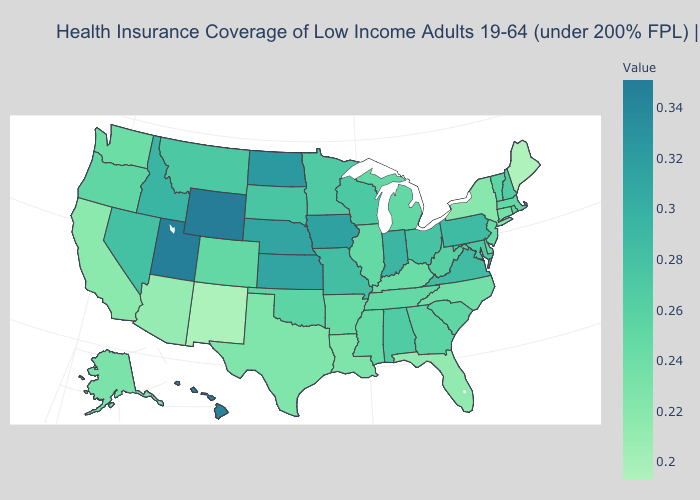Does the map have missing data?
Write a very short answer. No. Does Pennsylvania have a higher value than Iowa?
Write a very short answer. No. Among the states that border Iowa , which have the highest value?
Quick response, please. Nebraska. Which states have the highest value in the USA?
Give a very brief answer. Wyoming. Does the map have missing data?
Write a very short answer. No. Does Wyoming have the highest value in the USA?
Answer briefly. Yes. Which states have the highest value in the USA?
Short answer required. Wyoming. 